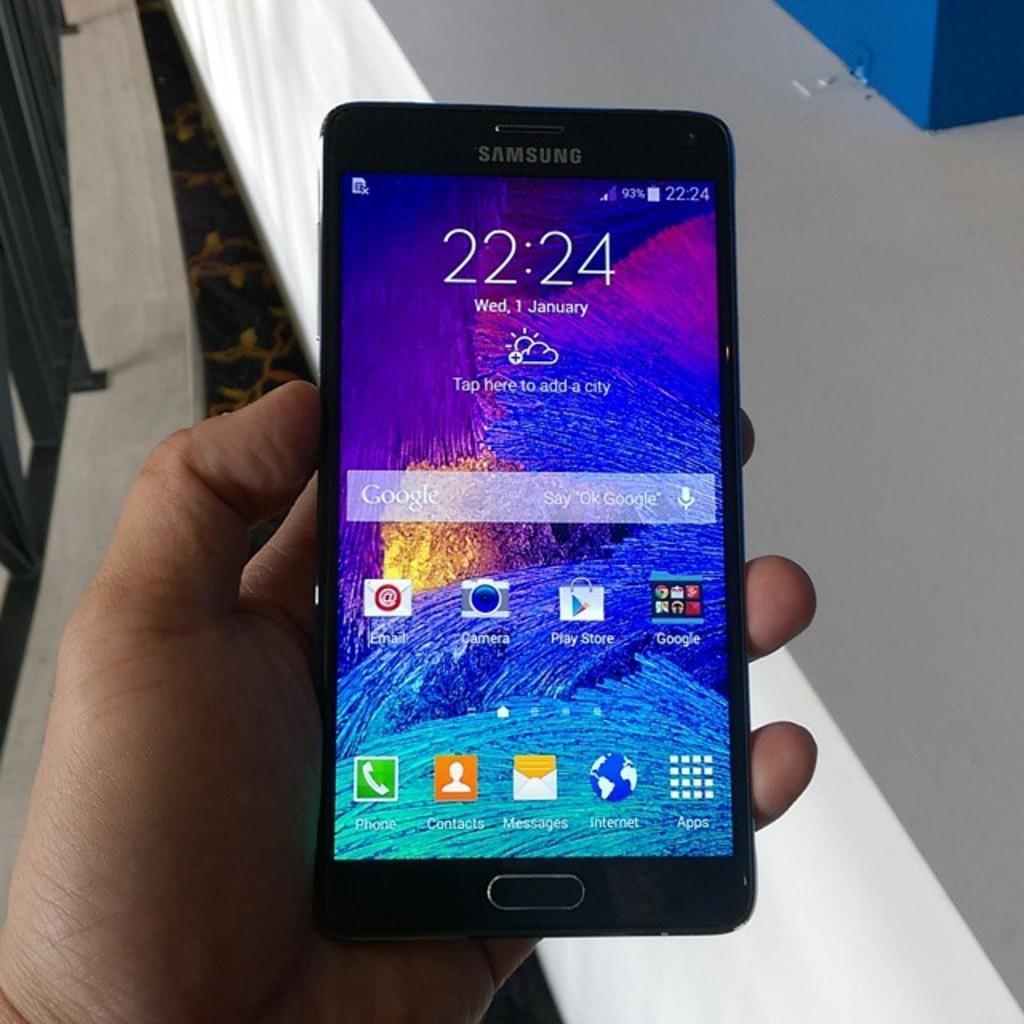How would you summarize this image in a sentence or two? This picture contains the hand of a human holding SAMSUNG phone. It is displaying icons, date and time. Beside that, we see a white table on which blue box is placed. This picture might be clicked inside the room. 